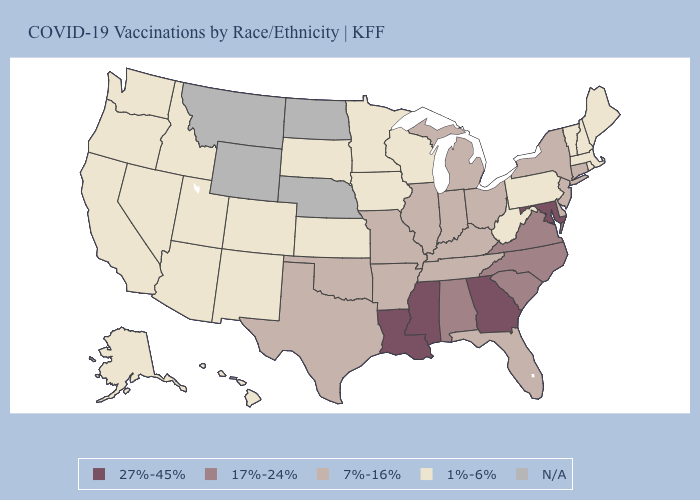Name the states that have a value in the range 27%-45%?
Concise answer only. Georgia, Louisiana, Maryland, Mississippi. Among the states that border Washington , which have the highest value?
Give a very brief answer. Idaho, Oregon. What is the value of Georgia?
Concise answer only. 27%-45%. Name the states that have a value in the range 1%-6%?
Keep it brief. Alaska, Arizona, California, Colorado, Hawaii, Idaho, Iowa, Kansas, Maine, Massachusetts, Minnesota, Nevada, New Hampshire, New Mexico, Oregon, Pennsylvania, Rhode Island, South Dakota, Utah, Vermont, Washington, West Virginia, Wisconsin. What is the value of Alaska?
Short answer required. 1%-6%. Name the states that have a value in the range 17%-24%?
Give a very brief answer. Alabama, North Carolina, South Carolina, Virginia. Name the states that have a value in the range 17%-24%?
Be succinct. Alabama, North Carolina, South Carolina, Virginia. Name the states that have a value in the range 17%-24%?
Answer briefly. Alabama, North Carolina, South Carolina, Virginia. Which states have the lowest value in the USA?
Answer briefly. Alaska, Arizona, California, Colorado, Hawaii, Idaho, Iowa, Kansas, Maine, Massachusetts, Minnesota, Nevada, New Hampshire, New Mexico, Oregon, Pennsylvania, Rhode Island, South Dakota, Utah, Vermont, Washington, West Virginia, Wisconsin. Which states have the lowest value in the South?
Answer briefly. West Virginia. What is the value of North Dakota?
Quick response, please. N/A. What is the highest value in the Northeast ?
Give a very brief answer. 7%-16%. 